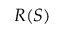<formula> <loc_0><loc_0><loc_500><loc_500>R ( S )</formula> 